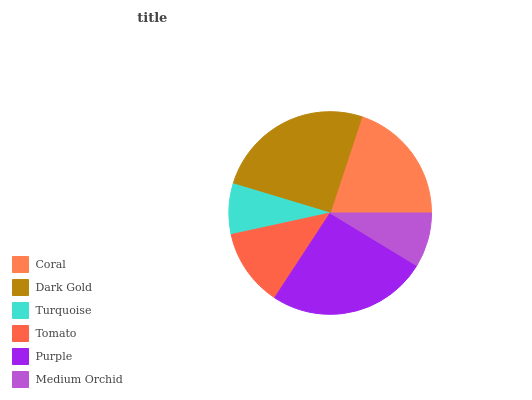Is Turquoise the minimum?
Answer yes or no. Yes. Is Purple the maximum?
Answer yes or no. Yes. Is Dark Gold the minimum?
Answer yes or no. No. Is Dark Gold the maximum?
Answer yes or no. No. Is Dark Gold greater than Coral?
Answer yes or no. Yes. Is Coral less than Dark Gold?
Answer yes or no. Yes. Is Coral greater than Dark Gold?
Answer yes or no. No. Is Dark Gold less than Coral?
Answer yes or no. No. Is Coral the high median?
Answer yes or no. Yes. Is Tomato the low median?
Answer yes or no. Yes. Is Medium Orchid the high median?
Answer yes or no. No. Is Turquoise the low median?
Answer yes or no. No. 